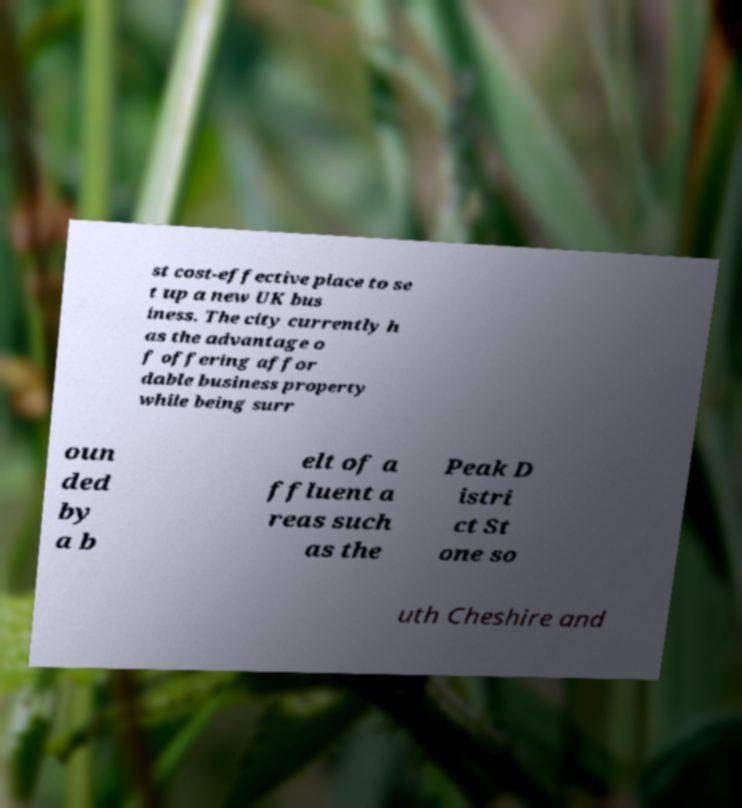Please read and relay the text visible in this image. What does it say? st cost-effective place to se t up a new UK bus iness. The city currently h as the advantage o f offering affor dable business property while being surr oun ded by a b elt of a ffluent a reas such as the Peak D istri ct St one so uth Cheshire and 